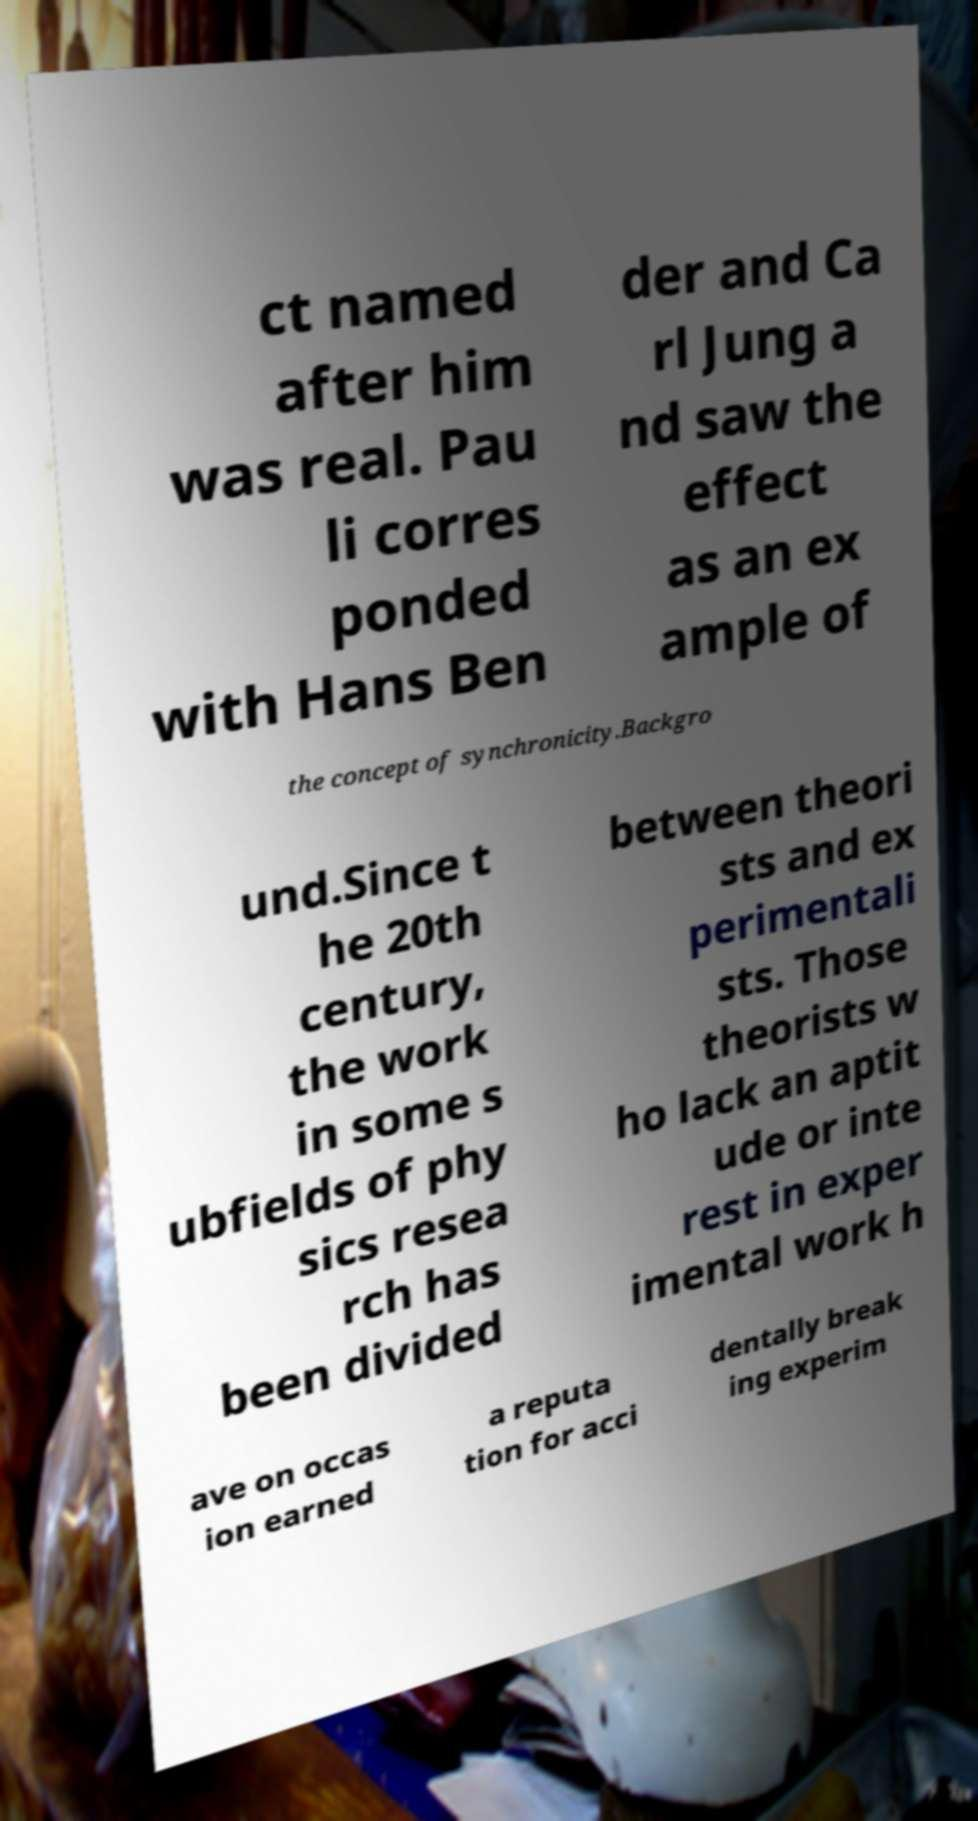I need the written content from this picture converted into text. Can you do that? ct named after him was real. Pau li corres ponded with Hans Ben der and Ca rl Jung a nd saw the effect as an ex ample of the concept of synchronicity.Backgro und.Since t he 20th century, the work in some s ubfields of phy sics resea rch has been divided between theori sts and ex perimentali sts. Those theorists w ho lack an aptit ude or inte rest in exper imental work h ave on occas ion earned a reputa tion for acci dentally break ing experim 